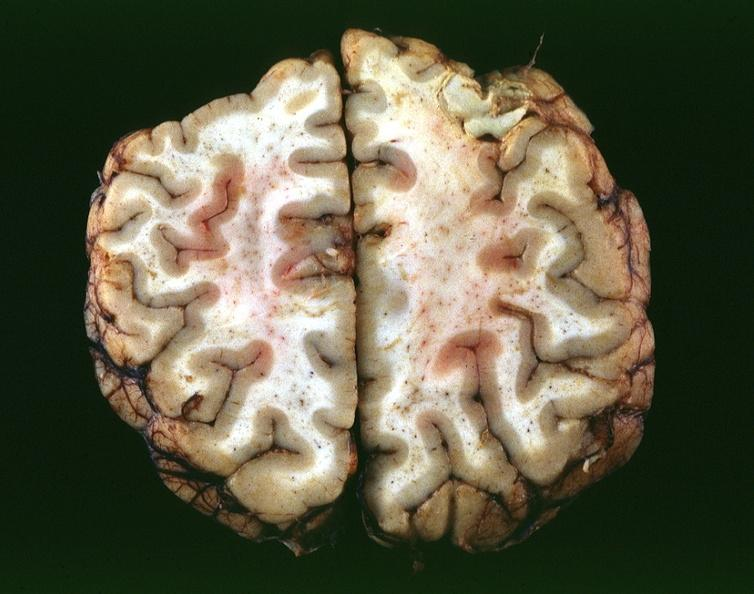does this image show toxoplasmosis, brain?
Answer the question using a single word or phrase. Yes 